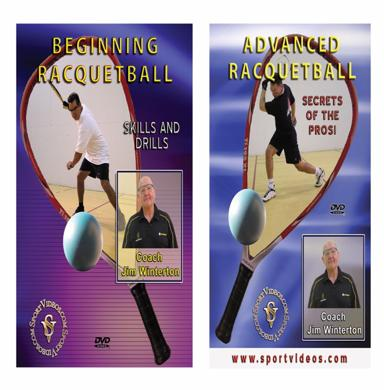What levels of racquetball instruction are offered in the DVDs mentioned in the image? The DVDs cater to various skill levels, providing detailed instructional content in 'Beginning Racquetball' for newcomers and 'Advanced Racquetball' for more experienced players. The latter release goes an extra mile by including a special segment titled 'Secrets of the Pros: Skills and Drills,' which dives deeper into expert techniques and training methods, allowing dedicated players to refine and elevate their gameplay. 